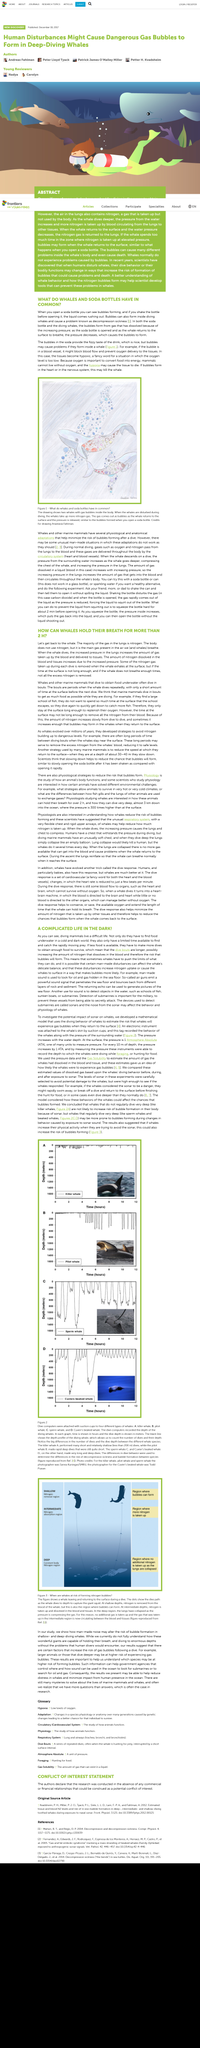Identify some key points in this picture. Decompression sickness in whales can cause hypoxia by creating bubbles in their blood vessels. Nitrogen increases due to increased pressure in the atmosphere. It is likely that if bubbles form in a whale's heart, the whale may die as a result. The main type of gas in the lungs is nitrogen. Whales utilize nitrogen gas to extend their breath-holding time for more than two hours. 